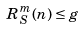Convert formula to latex. <formula><loc_0><loc_0><loc_500><loc_500>R _ { S } ^ { m } ( n ) \leq g</formula> 